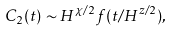Convert formula to latex. <formula><loc_0><loc_0><loc_500><loc_500>C _ { 2 } ( t ) \sim H ^ { \chi / 2 } f ( t / H ^ { z / 2 } ) ,</formula> 